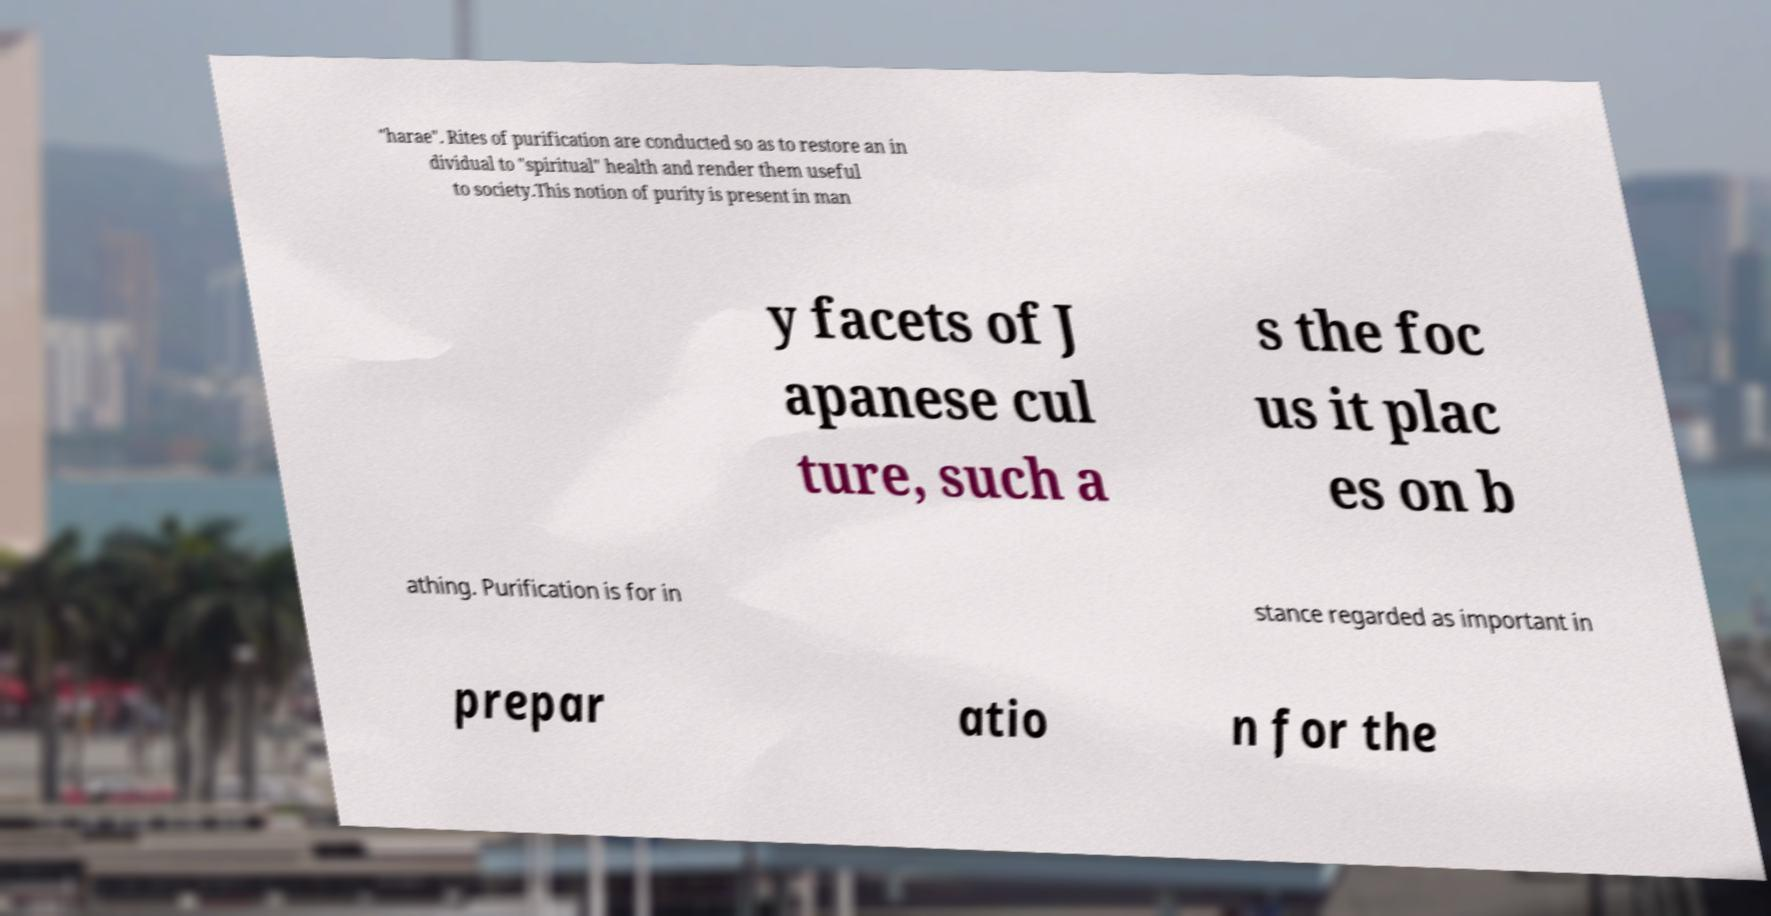Please read and relay the text visible in this image. What does it say? "harae". Rites of purification are conducted so as to restore an in dividual to "spiritual" health and render them useful to society.This notion of purity is present in man y facets of J apanese cul ture, such a s the foc us it plac es on b athing. Purification is for in stance regarded as important in prepar atio n for the 